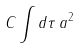<formula> <loc_0><loc_0><loc_500><loc_500>C \int d \tau \, a ^ { 2 }</formula> 